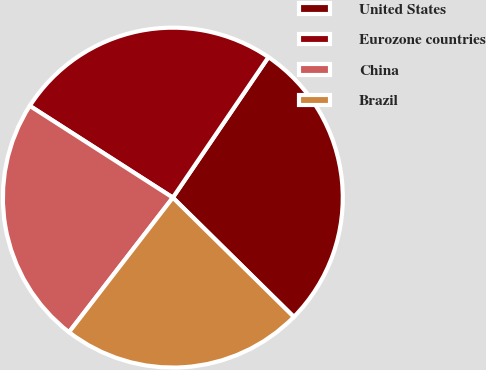Convert chart to OTSL. <chart><loc_0><loc_0><loc_500><loc_500><pie_chart><fcel>United States<fcel>Eurozone countries<fcel>China<fcel>Brazil<nl><fcel>27.88%<fcel>25.43%<fcel>23.62%<fcel>23.07%<nl></chart> 